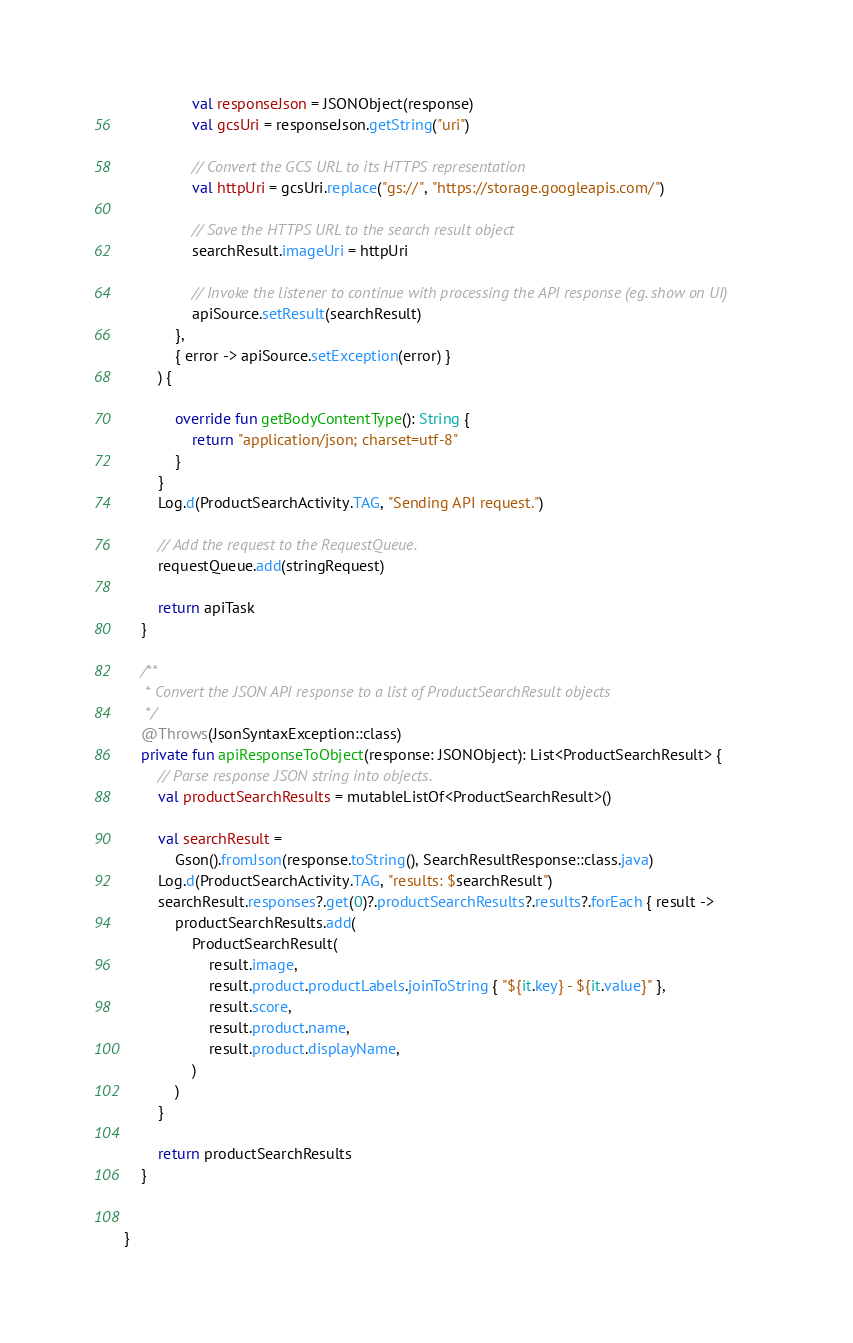Convert code to text. <code><loc_0><loc_0><loc_500><loc_500><_Kotlin_>                val responseJson = JSONObject(response)
                val gcsUri = responseJson.getString("uri")

                // Convert the GCS URL to its HTTPS representation
                val httpUri = gcsUri.replace("gs://", "https://storage.googleapis.com/")

                // Save the HTTPS URL to the search result object
                searchResult.imageUri = httpUri

                // Invoke the listener to continue with processing the API response (eg. show on UI)
                apiSource.setResult(searchResult)
            },
            { error -> apiSource.setException(error) }
        ) {

            override fun getBodyContentType(): String {
                return "application/json; charset=utf-8"
            }
        }
        Log.d(ProductSearchActivity.TAG, "Sending API request.")

        // Add the request to the RequestQueue.
        requestQueue.add(stringRequest)

        return apiTask
    }

    /**
     * Convert the JSON API response to a list of ProductSearchResult objects
     */
    @Throws(JsonSyntaxException::class)
    private fun apiResponseToObject(response: JSONObject): List<ProductSearchResult> {
        // Parse response JSON string into objects.
        val productSearchResults = mutableListOf<ProductSearchResult>()

        val searchResult =
            Gson().fromJson(response.toString(), SearchResultResponse::class.java)
        Log.d(ProductSearchActivity.TAG, "results: $searchResult")
        searchResult.responses?.get(0)?.productSearchResults?.results?.forEach { result ->
            productSearchResults.add(
                ProductSearchResult(
                    result.image,
                    result.product.productLabels.joinToString { "${it.key} - ${it.value}" },
                    result.score,
                    result.product.name,
                    result.product.displayName,
                )
            )
        }

        return productSearchResults
    }


}
</code> 